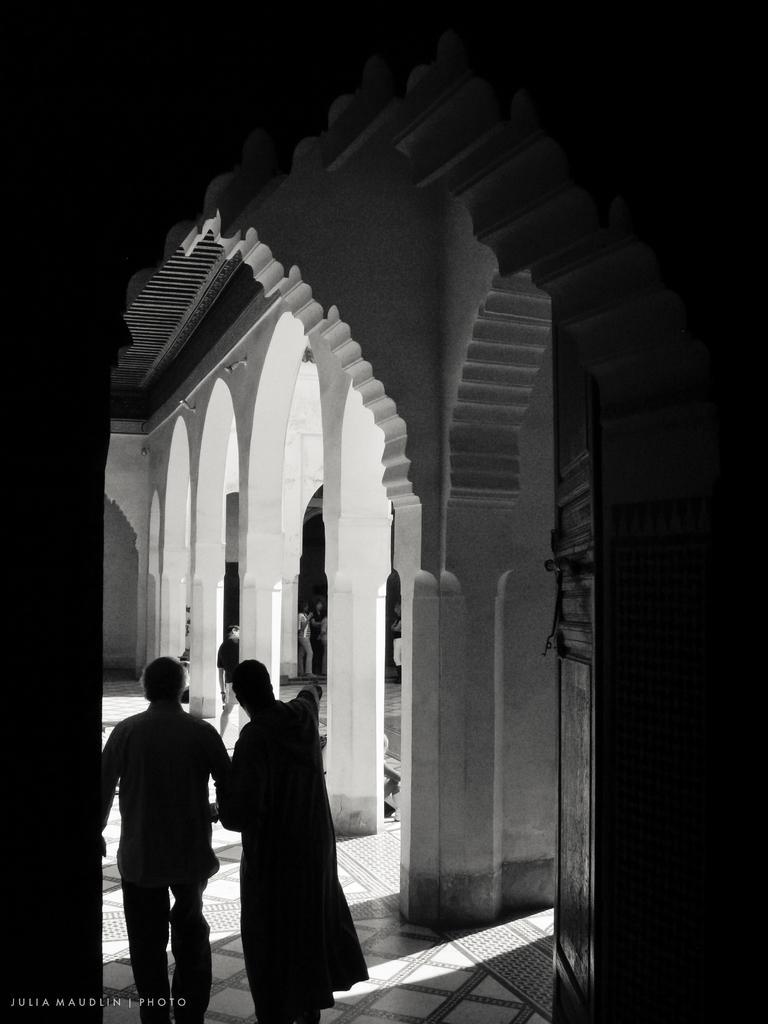How would you summarize this image in a sentence or two? In this picture we can see few people on the ground and in the background we can see pillars and the wall, in the bottom left we can see some text. 